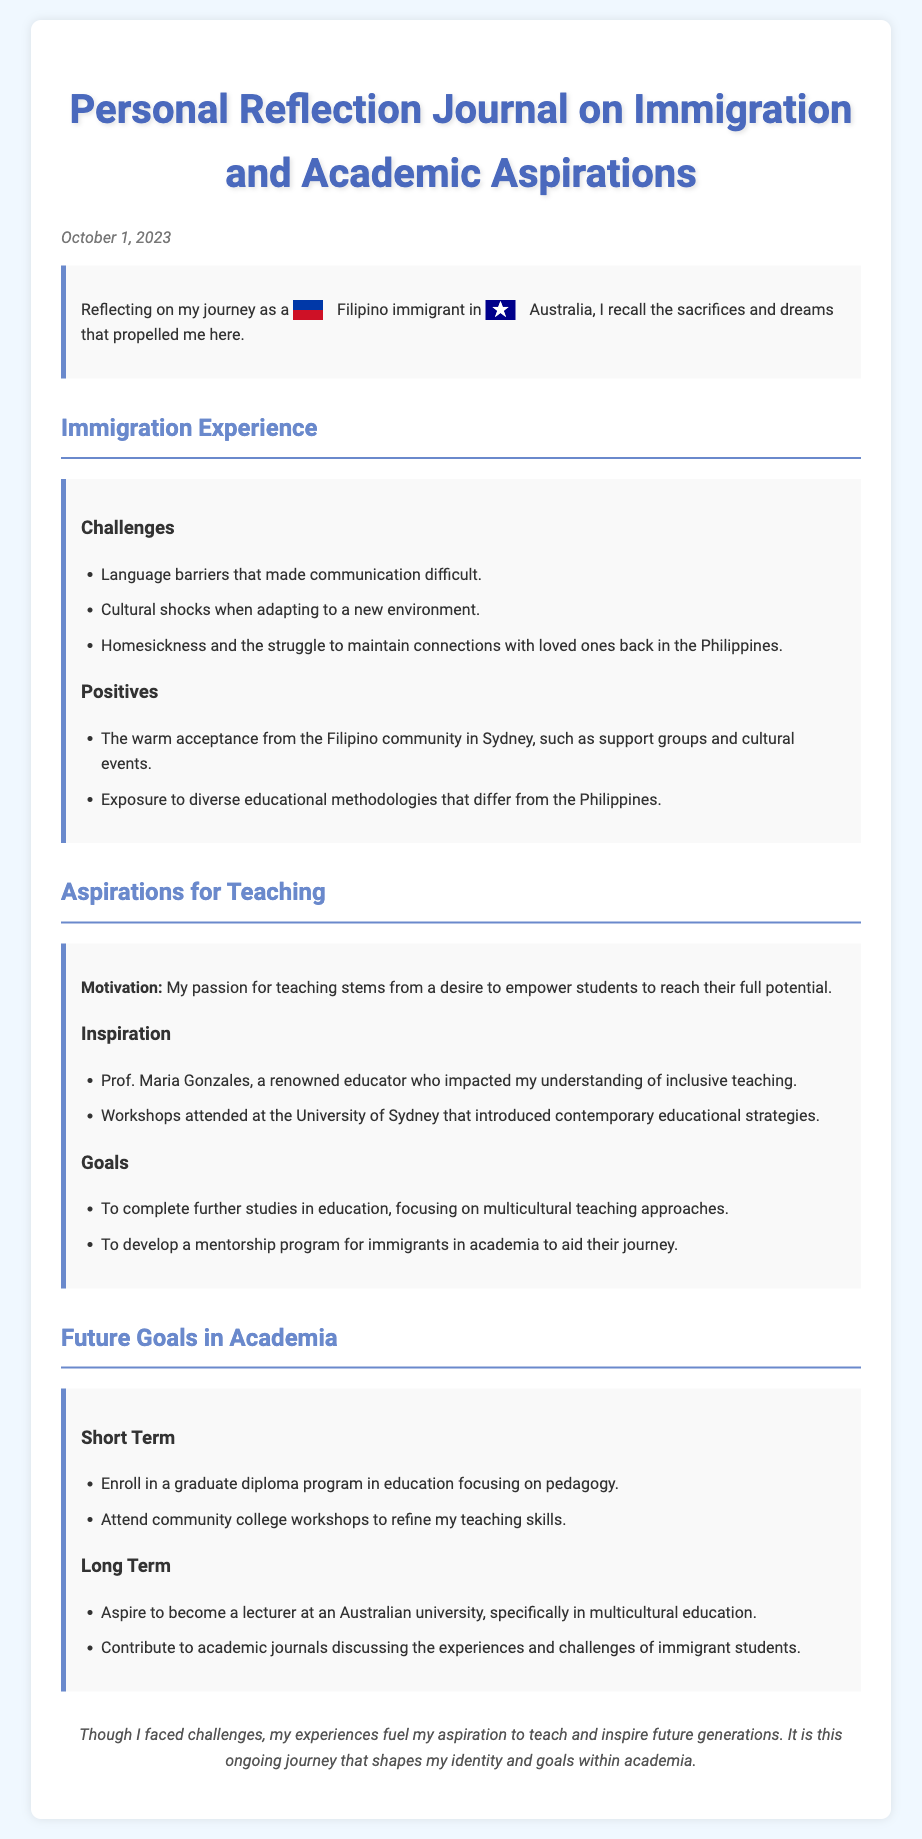What is the date of the journal entry? The date of the journal entry is provided at the start of the document, which is October 1, 2023.
Answer: October 1, 2023 Who is the professor mentioned as an inspiration? The document lists Prof. Maria Gonzales, who impacted the author's understanding of inclusive teaching, as an inspiration.
Answer: Prof. Maria Gonzales What community does the author mention finding support from? The author reflects on the warm acceptance from the Filipino community in Sydney as a source of support.
Answer: Filipino community What is one of the short-term goals in academia? The author mentions enrolling in a graduate diploma program in education focusing on pedagogy as a short-term goal.
Answer: Enroll in a graduate diploma program in education What is a challenge faced during the immigration experience? The challenges noted include language barriers that made communication difficult.
Answer: Language barriers What is a long-term aspiration in the author's goals? The long-term aspiration mentioned is to become a lecturer at an Australian university, specifically in multicultural education.
Answer: Lecturer at an Australian university What type of educational methodologies did the author gain exposure to? The author notes exposure to diverse educational methodologies that differ from the Philippines.
Answer: Diverse educational methodologies What is a goal related to mentorship mentioned in the document? The author aims to develop a mentorship program for immigrants in academia to aid their journey.
Answer: Mentorship program for immigrants in academia 